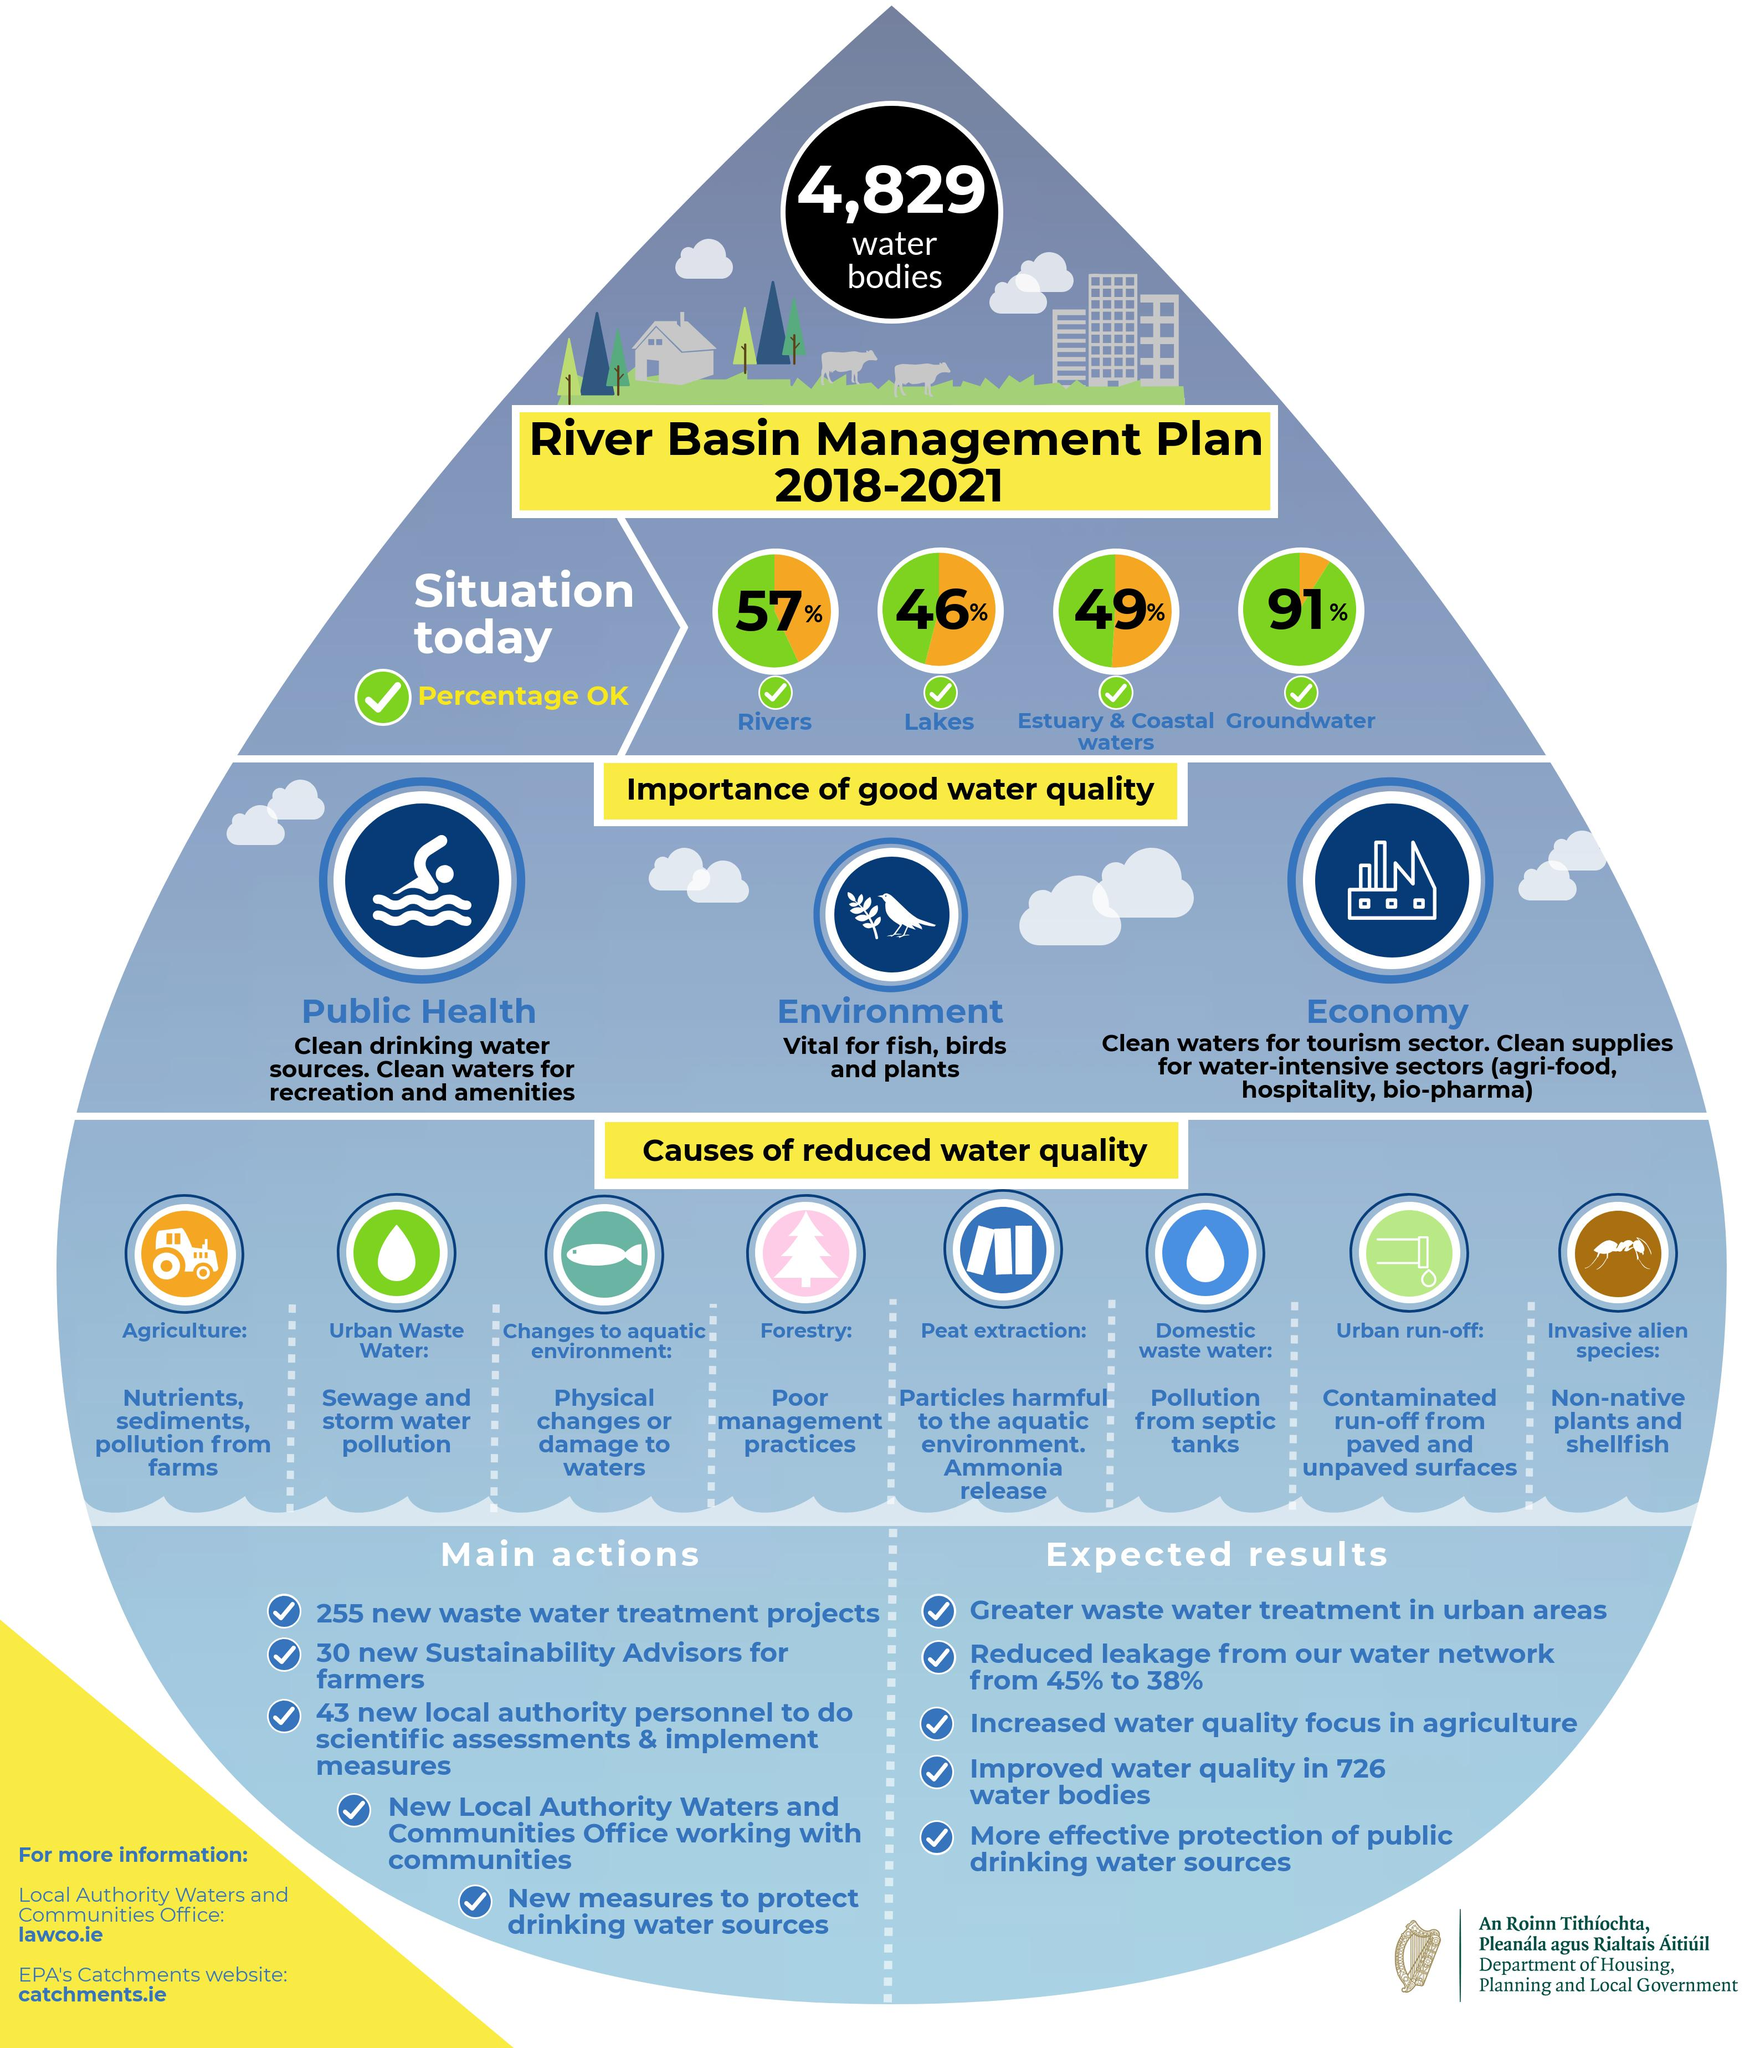Draw attention to some important aspects in this diagram. According to recent studies, 43% of the water in rivers is not safe for consumption. 